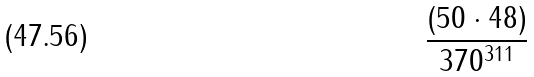Convert formula to latex. <formula><loc_0><loc_0><loc_500><loc_500>\frac { ( 5 0 \cdot 4 8 ) } { 3 7 0 ^ { 3 1 1 } }</formula> 